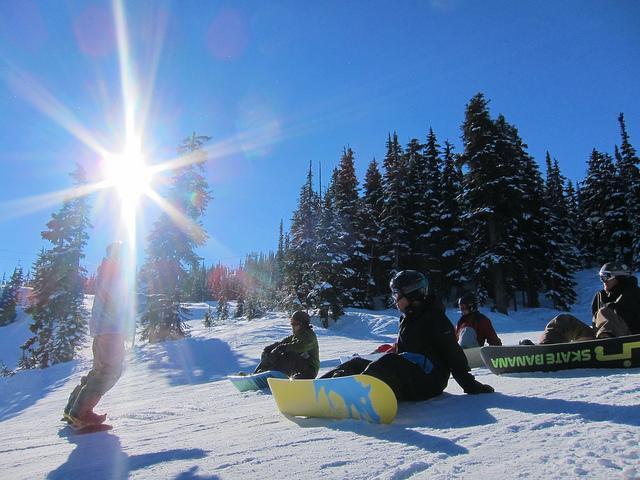Who is the man standing in front of the group?
Select the accurate answer and provide explanation: 'Answer: answer
Rationale: rationale.'
Options: Uncle, father, pastor, instructor. Answer: instructor.
Rationale: The people who are learning are siting down. when a teacher is teaching the students are sitting down. 